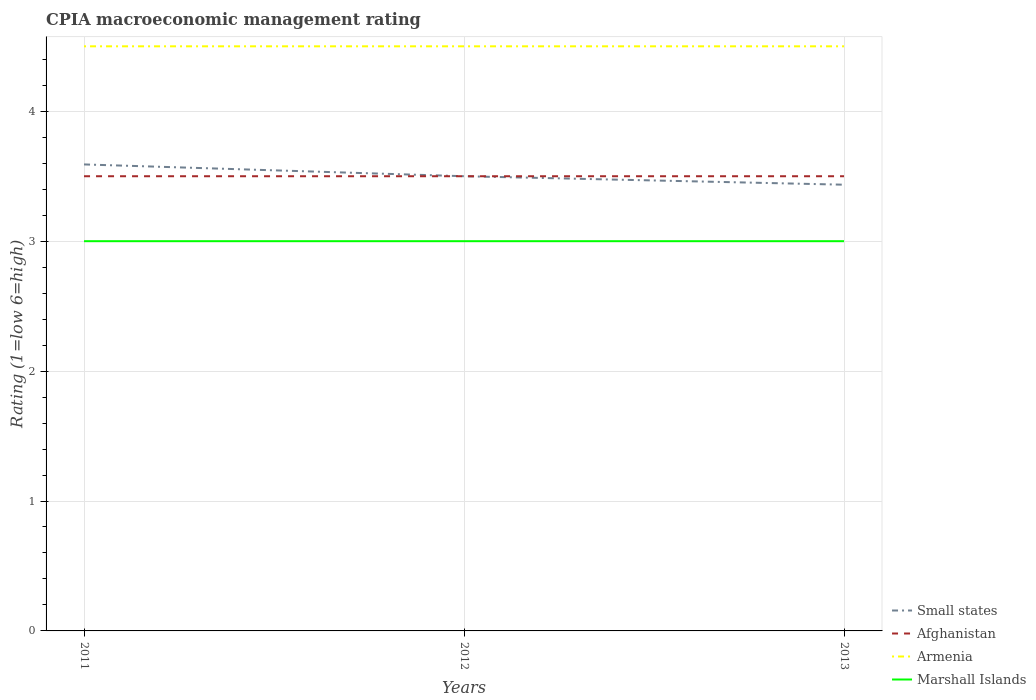How many different coloured lines are there?
Ensure brevity in your answer.  4. Across all years, what is the maximum CPIA rating in Marshall Islands?
Give a very brief answer. 3. What is the total CPIA rating in Marshall Islands in the graph?
Ensure brevity in your answer.  0. What is the difference between the highest and the second highest CPIA rating in Small states?
Keep it short and to the point. 0.16. How many lines are there?
Ensure brevity in your answer.  4. What is the difference between two consecutive major ticks on the Y-axis?
Keep it short and to the point. 1. Are the values on the major ticks of Y-axis written in scientific E-notation?
Offer a terse response. No. Does the graph contain any zero values?
Provide a short and direct response. No. Does the graph contain grids?
Offer a terse response. Yes. How many legend labels are there?
Ensure brevity in your answer.  4. What is the title of the graph?
Provide a short and direct response. CPIA macroeconomic management rating. What is the label or title of the X-axis?
Your response must be concise. Years. What is the Rating (1=low 6=high) in Small states in 2011?
Offer a terse response. 3.59. What is the Rating (1=low 6=high) in Afghanistan in 2011?
Make the answer very short. 3.5. What is the Rating (1=low 6=high) in Marshall Islands in 2011?
Give a very brief answer. 3. What is the Rating (1=low 6=high) in Armenia in 2012?
Provide a short and direct response. 4.5. What is the Rating (1=low 6=high) in Marshall Islands in 2012?
Ensure brevity in your answer.  3. What is the Rating (1=low 6=high) in Small states in 2013?
Provide a short and direct response. 3.43. What is the Rating (1=low 6=high) of Armenia in 2013?
Offer a terse response. 4.5. Across all years, what is the maximum Rating (1=low 6=high) of Small states?
Keep it short and to the point. 3.59. Across all years, what is the maximum Rating (1=low 6=high) of Afghanistan?
Make the answer very short. 3.5. Across all years, what is the minimum Rating (1=low 6=high) of Small states?
Give a very brief answer. 3.43. Across all years, what is the minimum Rating (1=low 6=high) in Afghanistan?
Keep it short and to the point. 3.5. Across all years, what is the minimum Rating (1=low 6=high) of Marshall Islands?
Provide a succinct answer. 3. What is the total Rating (1=low 6=high) of Small states in the graph?
Offer a terse response. 10.53. What is the total Rating (1=low 6=high) in Afghanistan in the graph?
Provide a succinct answer. 10.5. What is the total Rating (1=low 6=high) in Armenia in the graph?
Ensure brevity in your answer.  13.5. What is the total Rating (1=low 6=high) in Marshall Islands in the graph?
Your response must be concise. 9. What is the difference between the Rating (1=low 6=high) in Small states in 2011 and that in 2012?
Offer a very short reply. 0.09. What is the difference between the Rating (1=low 6=high) of Afghanistan in 2011 and that in 2012?
Provide a short and direct response. 0. What is the difference between the Rating (1=low 6=high) of Armenia in 2011 and that in 2012?
Offer a terse response. 0. What is the difference between the Rating (1=low 6=high) in Marshall Islands in 2011 and that in 2012?
Keep it short and to the point. 0. What is the difference between the Rating (1=low 6=high) of Small states in 2011 and that in 2013?
Offer a terse response. 0.16. What is the difference between the Rating (1=low 6=high) in Afghanistan in 2011 and that in 2013?
Your response must be concise. 0. What is the difference between the Rating (1=low 6=high) of Armenia in 2011 and that in 2013?
Your answer should be very brief. 0. What is the difference between the Rating (1=low 6=high) in Marshall Islands in 2011 and that in 2013?
Offer a very short reply. 0. What is the difference between the Rating (1=low 6=high) of Small states in 2012 and that in 2013?
Ensure brevity in your answer.  0.07. What is the difference between the Rating (1=low 6=high) in Afghanistan in 2012 and that in 2013?
Offer a very short reply. 0. What is the difference between the Rating (1=low 6=high) of Armenia in 2012 and that in 2013?
Provide a succinct answer. 0. What is the difference between the Rating (1=low 6=high) of Small states in 2011 and the Rating (1=low 6=high) of Afghanistan in 2012?
Provide a succinct answer. 0.09. What is the difference between the Rating (1=low 6=high) in Small states in 2011 and the Rating (1=low 6=high) in Armenia in 2012?
Ensure brevity in your answer.  -0.91. What is the difference between the Rating (1=low 6=high) of Small states in 2011 and the Rating (1=low 6=high) of Marshall Islands in 2012?
Make the answer very short. 0.59. What is the difference between the Rating (1=low 6=high) of Afghanistan in 2011 and the Rating (1=low 6=high) of Armenia in 2012?
Give a very brief answer. -1. What is the difference between the Rating (1=low 6=high) in Afghanistan in 2011 and the Rating (1=low 6=high) in Marshall Islands in 2012?
Your answer should be very brief. 0.5. What is the difference between the Rating (1=low 6=high) of Armenia in 2011 and the Rating (1=low 6=high) of Marshall Islands in 2012?
Offer a terse response. 1.5. What is the difference between the Rating (1=low 6=high) in Small states in 2011 and the Rating (1=low 6=high) in Afghanistan in 2013?
Give a very brief answer. 0.09. What is the difference between the Rating (1=low 6=high) in Small states in 2011 and the Rating (1=low 6=high) in Armenia in 2013?
Your answer should be compact. -0.91. What is the difference between the Rating (1=low 6=high) of Small states in 2011 and the Rating (1=low 6=high) of Marshall Islands in 2013?
Provide a short and direct response. 0.59. What is the difference between the Rating (1=low 6=high) of Afghanistan in 2011 and the Rating (1=low 6=high) of Marshall Islands in 2013?
Your answer should be very brief. 0.5. What is the difference between the Rating (1=low 6=high) in Small states in 2012 and the Rating (1=low 6=high) in Afghanistan in 2013?
Provide a short and direct response. 0. What is the difference between the Rating (1=low 6=high) of Small states in 2012 and the Rating (1=low 6=high) of Armenia in 2013?
Offer a terse response. -1. What is the difference between the Rating (1=low 6=high) in Small states in 2012 and the Rating (1=low 6=high) in Marshall Islands in 2013?
Offer a very short reply. 0.5. What is the difference between the Rating (1=low 6=high) in Afghanistan in 2012 and the Rating (1=low 6=high) in Armenia in 2013?
Give a very brief answer. -1. What is the difference between the Rating (1=low 6=high) in Afghanistan in 2012 and the Rating (1=low 6=high) in Marshall Islands in 2013?
Your response must be concise. 0.5. What is the difference between the Rating (1=low 6=high) in Armenia in 2012 and the Rating (1=low 6=high) in Marshall Islands in 2013?
Make the answer very short. 1.5. What is the average Rating (1=low 6=high) of Small states per year?
Ensure brevity in your answer.  3.51. In the year 2011, what is the difference between the Rating (1=low 6=high) in Small states and Rating (1=low 6=high) in Afghanistan?
Provide a short and direct response. 0.09. In the year 2011, what is the difference between the Rating (1=low 6=high) of Small states and Rating (1=low 6=high) of Armenia?
Offer a very short reply. -0.91. In the year 2011, what is the difference between the Rating (1=low 6=high) of Small states and Rating (1=low 6=high) of Marshall Islands?
Give a very brief answer. 0.59. In the year 2011, what is the difference between the Rating (1=low 6=high) of Afghanistan and Rating (1=low 6=high) of Armenia?
Your answer should be very brief. -1. In the year 2011, what is the difference between the Rating (1=low 6=high) of Afghanistan and Rating (1=low 6=high) of Marshall Islands?
Your answer should be compact. 0.5. In the year 2011, what is the difference between the Rating (1=low 6=high) of Armenia and Rating (1=low 6=high) of Marshall Islands?
Offer a very short reply. 1.5. In the year 2012, what is the difference between the Rating (1=low 6=high) in Small states and Rating (1=low 6=high) in Afghanistan?
Offer a terse response. 0. In the year 2012, what is the difference between the Rating (1=low 6=high) of Small states and Rating (1=low 6=high) of Armenia?
Provide a succinct answer. -1. In the year 2012, what is the difference between the Rating (1=low 6=high) of Afghanistan and Rating (1=low 6=high) of Armenia?
Offer a very short reply. -1. In the year 2012, what is the difference between the Rating (1=low 6=high) of Afghanistan and Rating (1=low 6=high) of Marshall Islands?
Your answer should be compact. 0.5. In the year 2013, what is the difference between the Rating (1=low 6=high) in Small states and Rating (1=low 6=high) in Afghanistan?
Keep it short and to the point. -0.07. In the year 2013, what is the difference between the Rating (1=low 6=high) of Small states and Rating (1=low 6=high) of Armenia?
Offer a terse response. -1.07. In the year 2013, what is the difference between the Rating (1=low 6=high) of Small states and Rating (1=low 6=high) of Marshall Islands?
Your response must be concise. 0.43. In the year 2013, what is the difference between the Rating (1=low 6=high) of Afghanistan and Rating (1=low 6=high) of Armenia?
Make the answer very short. -1. In the year 2013, what is the difference between the Rating (1=low 6=high) of Armenia and Rating (1=low 6=high) of Marshall Islands?
Your answer should be compact. 1.5. What is the ratio of the Rating (1=low 6=high) of Small states in 2011 to that in 2012?
Provide a succinct answer. 1.03. What is the ratio of the Rating (1=low 6=high) in Marshall Islands in 2011 to that in 2012?
Make the answer very short. 1. What is the ratio of the Rating (1=low 6=high) in Small states in 2011 to that in 2013?
Make the answer very short. 1.05. What is the ratio of the Rating (1=low 6=high) of Afghanistan in 2011 to that in 2013?
Your answer should be very brief. 1. What is the ratio of the Rating (1=low 6=high) of Marshall Islands in 2011 to that in 2013?
Offer a terse response. 1. What is the ratio of the Rating (1=low 6=high) in Armenia in 2012 to that in 2013?
Provide a succinct answer. 1. What is the difference between the highest and the second highest Rating (1=low 6=high) in Small states?
Provide a succinct answer. 0.09. What is the difference between the highest and the second highest Rating (1=low 6=high) of Afghanistan?
Your answer should be very brief. 0. What is the difference between the highest and the lowest Rating (1=low 6=high) of Small states?
Offer a terse response. 0.16. What is the difference between the highest and the lowest Rating (1=low 6=high) of Afghanistan?
Offer a very short reply. 0. What is the difference between the highest and the lowest Rating (1=low 6=high) in Armenia?
Your answer should be compact. 0. What is the difference between the highest and the lowest Rating (1=low 6=high) in Marshall Islands?
Offer a terse response. 0. 